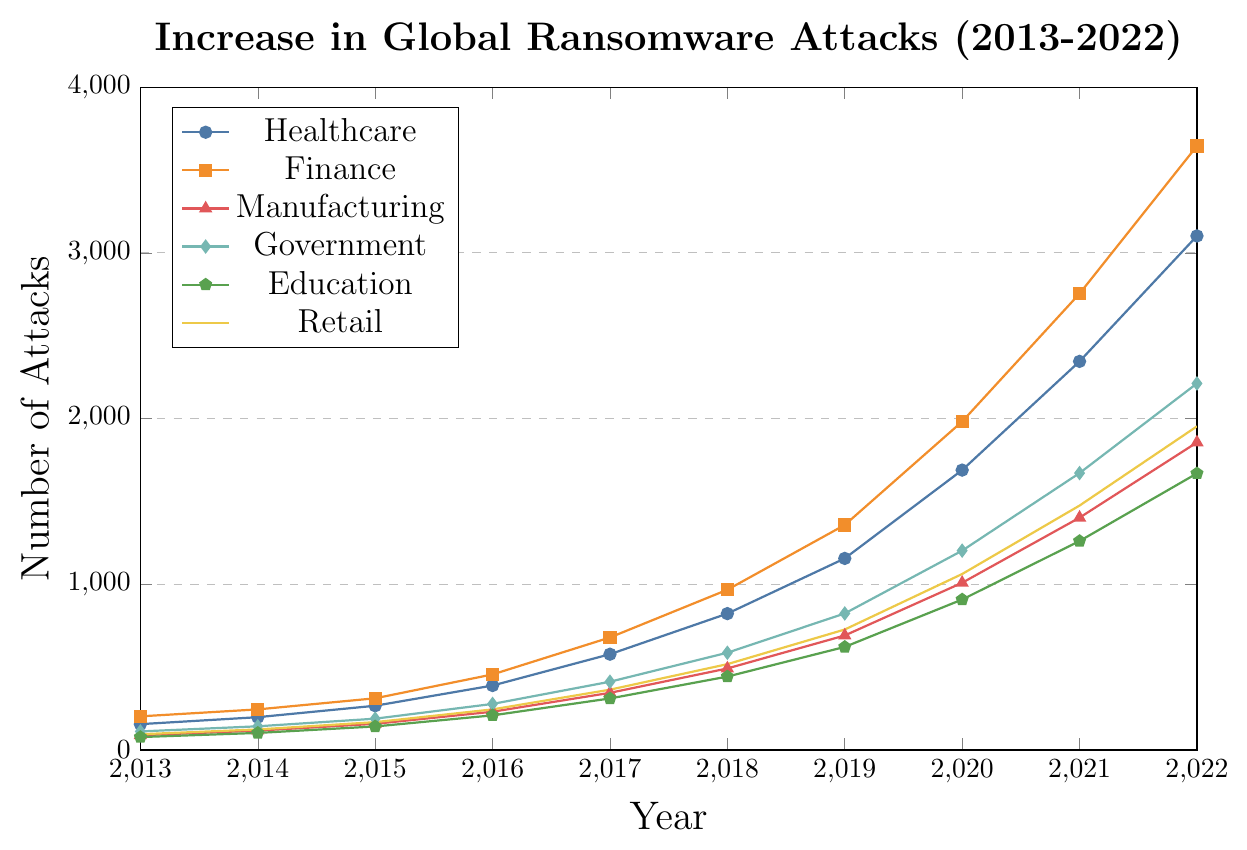Which industry experienced the largest increase in ransomware attacks from 2013 to 2022? To determine the industry with the largest increase, we subtract the number of attacks in 2013 from the number in 2022 for each industry and compare the differences. Healthcare: 3102-156=2946, Finance: 3645-203=3442, Manufacturing: 1856-89=1767, Government: 2212-112=2100, Education: 1669-78=1591, Retail: 1953-95=1858. Finance has the largest increase.
Answer: Finance Which industry had the fewest ransomware attacks in 2016? By examining the data points for 2016, we see Healthcare: 389, Finance: 456, Manufacturing: 231, Government: 278, Education: 209, Retail: 245. Education had the fewest attacks.
Answer: Education How many total ransomware attacks were there across all industries in 2017? We sum the number of attacks for each industry in 2017: 578 (Healthcare) + 679 (Finance) + 345 (Manufacturing) + 412 (Government) + 311 (Education) + 364 (Retail). The total is 2689.
Answer: 2689 Between which consecutive years did Healthcare see the largest increase in ransomware attacks? We calculate the year-to-year difference in attacks for Healthcare: 156 to 198 (42), 198 to 267 (69), 267 to 389 (122), 389 to 578 (189), 578 to 823 (245), 823 to 1156 (333), 1156 to 1689 (533), 1689 to 2345 (656), 2345 to 3102 (757). The largest increase is from 2021 to 2022.
Answer: 2021 to 2022 In 2020, which industry had the closest number of ransomware attacks to the average number of attacks across all industries? First, we find the average number of attacks across all industries in 2020: (1689 + 1982 + 1009 + 1203 + 908 + 1062) / 6 = 1142.16. Comparing each industry's attacks: Healthcare (1689), Finance (1982), Manufacturing (1009), Government (1203), Education (908), Retail (1062), we see that Manufacturing's 1009 is closest to this average.
Answer: Manufacturing Which industry showed an upward trend without any dips from 2013 to 2022? By examining the plots, we note that for Finance, the number of attacks increased each year without any decrease: 203, 245, 312, 456, 679, 967, 1358, 1982, 2754, 3645. Finance is always on the rise.
Answer: Finance How did the number of ransomware attacks in education in 2020 compare to those in government in the same year? Comparing the data points in 2020, Education had 908 attacks while Government had 1203 attacks, so Education had fewer attacks than Government.
Answer: Education had fewer attacks 